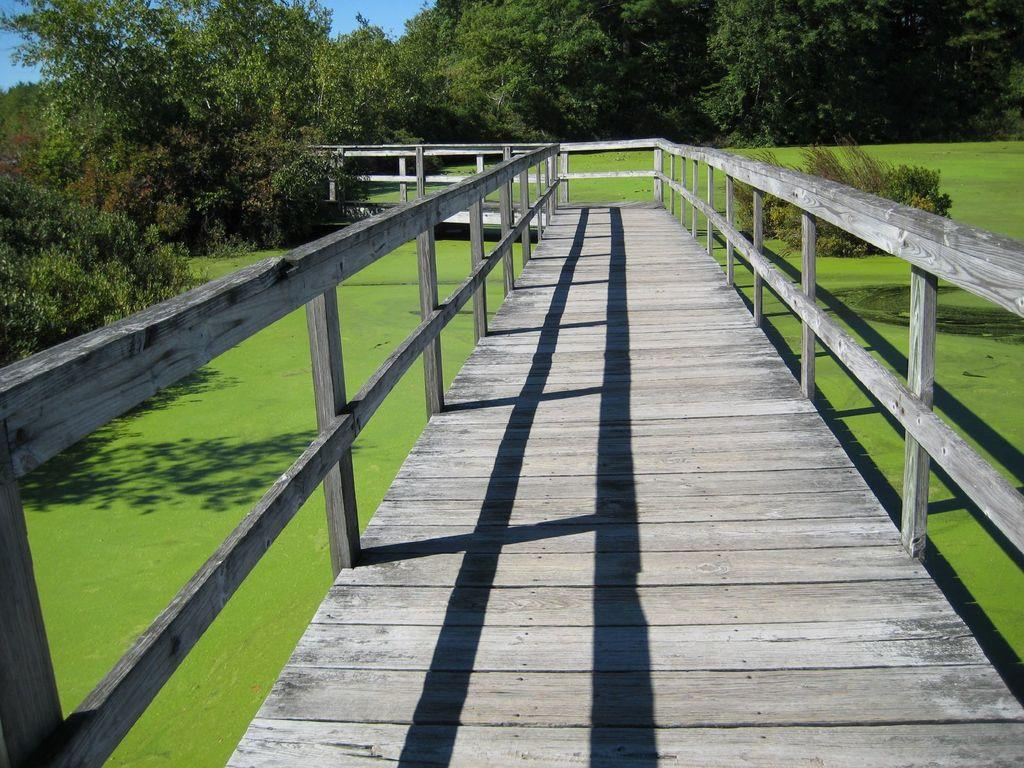What type of structure is present in the image? There is a wooden bridge in the image. What feature can be seen on both sides of the bridge? The bridge has railings on both sides. What can be seen in the distance behind the bridge? There are trees visible in the background. What type of landscape is at the bottom of the image? There is a green lawn at the bottom of the image. What color is the curtain hanging from the bridge in the image? There is no curtain present in the image; it is a wooden bridge with railings. 